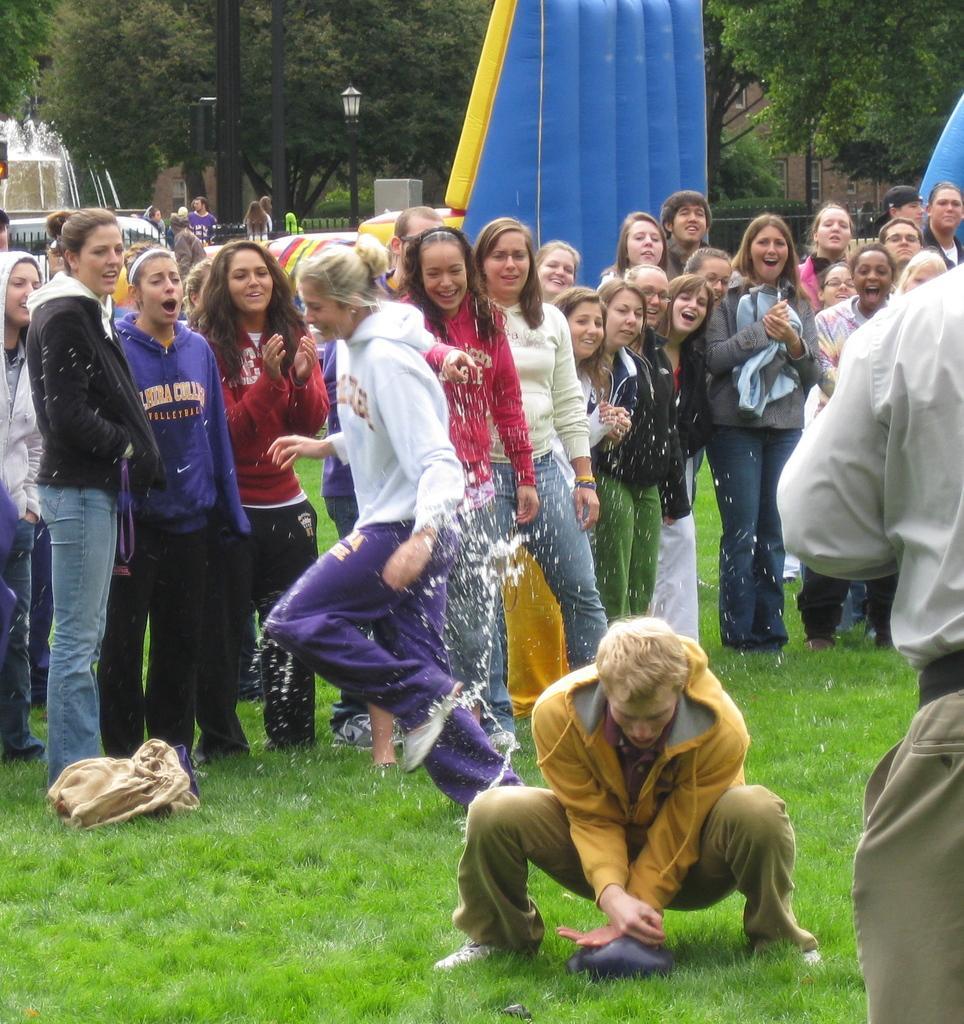Could you give a brief overview of what you see in this image? In the image there is a man with yellow hoodie and pants sitting on grass land, behind him there is a woman in white hoodie and purple pants running with water sprinkling all over her and behind there are many girls standing and laughing, over the back there are many trees all over the image with some people walking on it over the left side. 